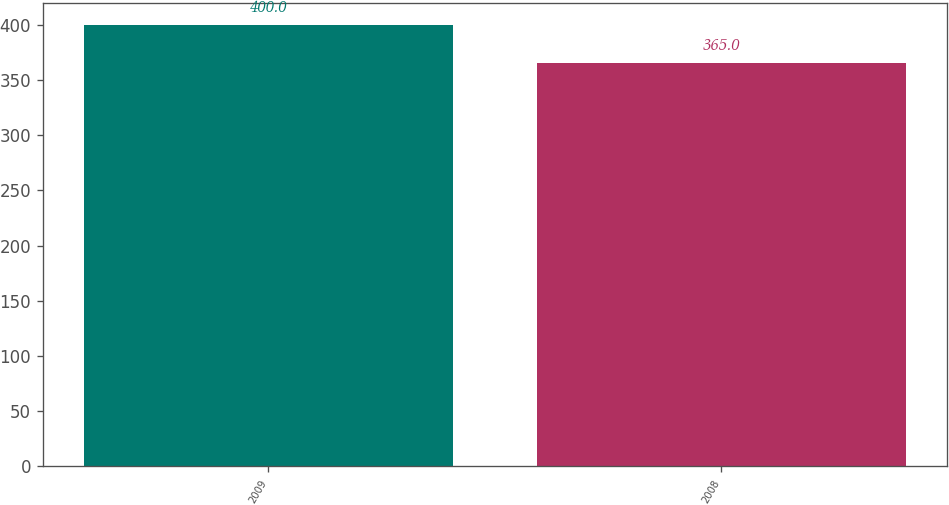Convert chart. <chart><loc_0><loc_0><loc_500><loc_500><bar_chart><fcel>2009<fcel>2008<nl><fcel>400<fcel>365<nl></chart> 